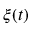<formula> <loc_0><loc_0><loc_500><loc_500>\xi ( t )</formula> 